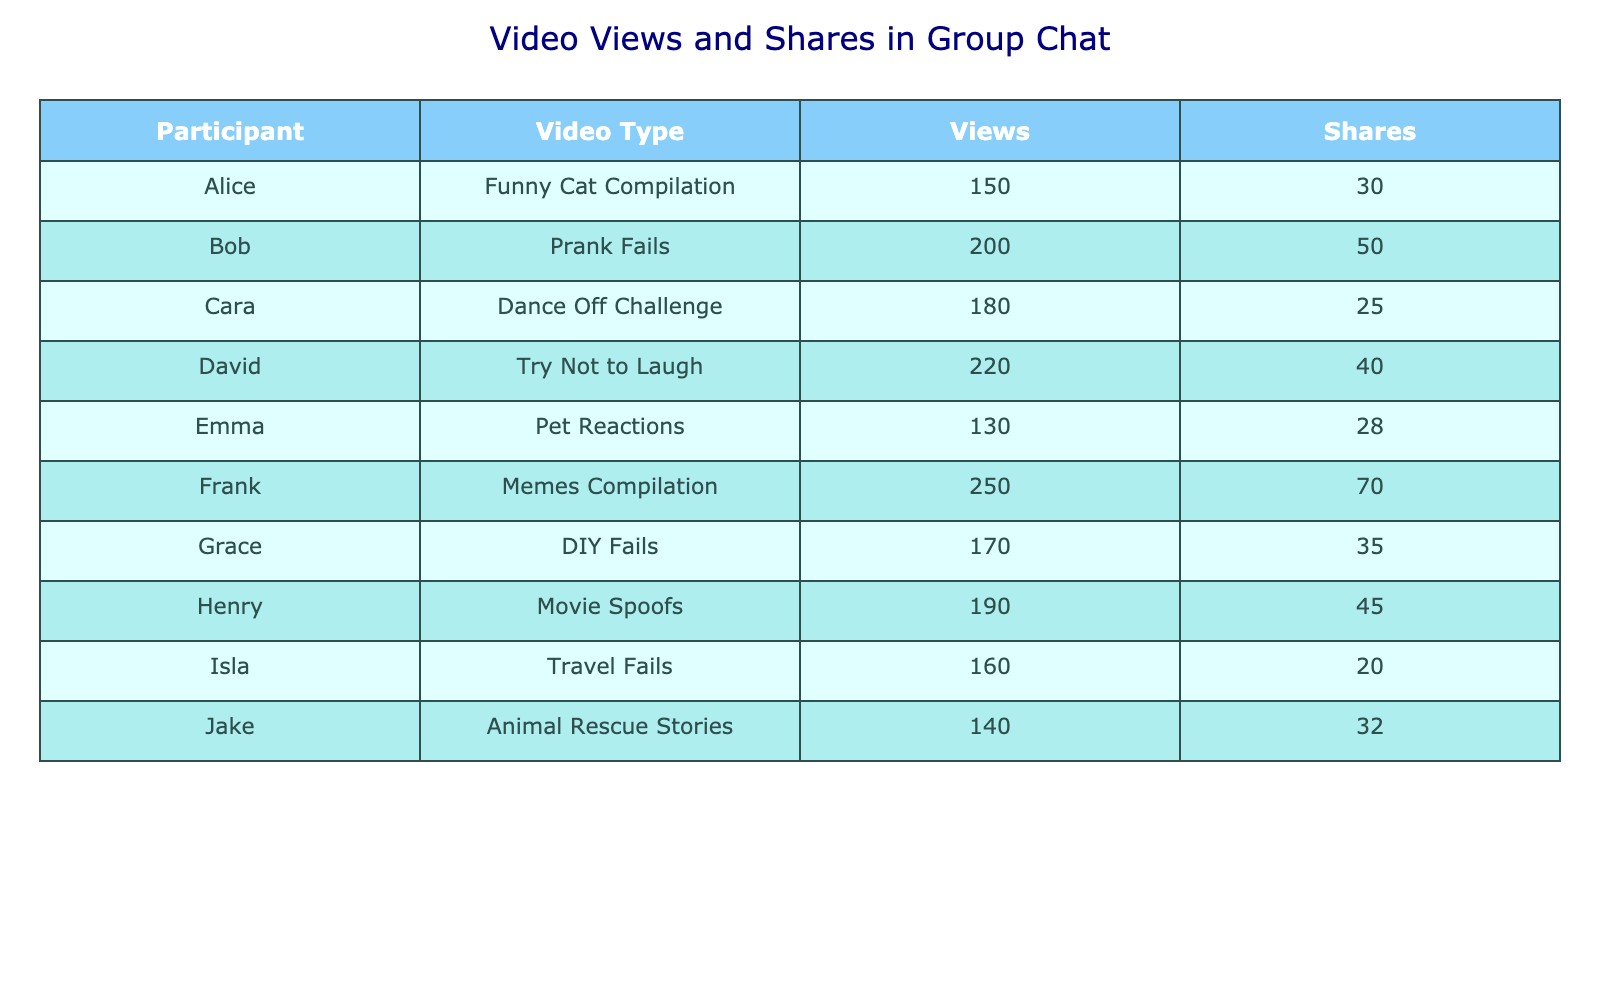What video type has the highest number of views? By scanning the "Views" column, we see the highest value is 250, which corresponds to the "Memes Compilation" video type associated with Frank.
Answer: Memes Compilation Which participant shared the "Try Not to Laugh" video? The "Try Not to Laugh" video is linked to David, as identified in the "Participant" column next to this video type.
Answer: David What is the total number of shares for all the videos? We need to add all the values from the "Shares" column: 30 + 50 + 25 + 40 + 28 + 70 + 35 + 45 + 20 + 32 = 400. Therefore, the total number of shares is 400.
Answer: 400 Is there any video with more than 200 views? Looking through the "Views" column, there are videos with values: 220 and 250 that exceed 200 views. Hence, the statement is true.
Answer: Yes What is the average number of views across all video types? We calculate the total views: 150 + 200 + 180 + 220 + 130 + 250 + 170 + 190 + 160 + 140 = 1950. There are 10 videos, so dividing 1950 by 10 gives 195.
Answer: 195 Which video type has the least number of shares? By reviewing the "Shares" column, the lowest value is 20, belonging to the "Travel Fails" video by Isla.
Answer: Travel Fails Who has the highest number of shares and how many? Frank has the highest number of shares with a value of 70, as seen in the "Shares" column next to his entry with the "Memes Compilation" video.
Answer: Frank, 70 How many more views does the "Prank Fails" video have compared to the "Pet Reactions" video? The "Prank Fails" video has 200 views and "Pet Reactions" has 130 views. The difference is 200 - 130 = 70.
Answer: 70 How many participants received fewer than 35 shares? Looking at the "Shares" column, participants Emma (28), Cara (25), and Isla (20) have fewer than 35 shares. That's a total of 3 participants.
Answer: 3 